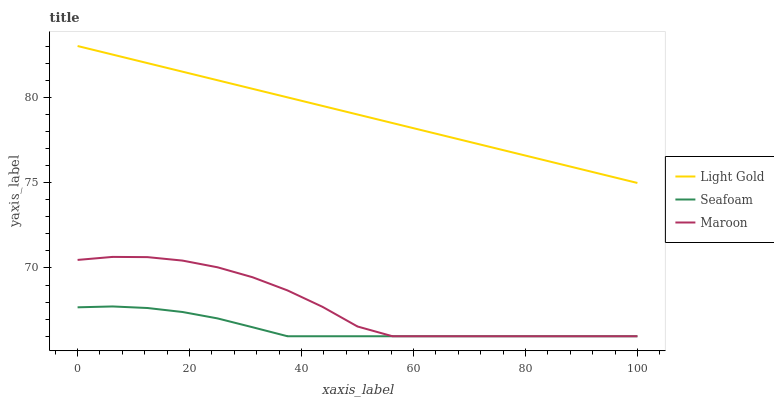Does Seafoam have the minimum area under the curve?
Answer yes or no. Yes. Does Light Gold have the maximum area under the curve?
Answer yes or no. Yes. Does Maroon have the minimum area under the curve?
Answer yes or no. No. Does Maroon have the maximum area under the curve?
Answer yes or no. No. Is Light Gold the smoothest?
Answer yes or no. Yes. Is Maroon the roughest?
Answer yes or no. Yes. Is Seafoam the smoothest?
Answer yes or no. No. Is Seafoam the roughest?
Answer yes or no. No. Does Seafoam have the lowest value?
Answer yes or no. Yes. Does Light Gold have the highest value?
Answer yes or no. Yes. Does Maroon have the highest value?
Answer yes or no. No. Is Maroon less than Light Gold?
Answer yes or no. Yes. Is Light Gold greater than Maroon?
Answer yes or no. Yes. Does Seafoam intersect Maroon?
Answer yes or no. Yes. Is Seafoam less than Maroon?
Answer yes or no. No. Is Seafoam greater than Maroon?
Answer yes or no. No. Does Maroon intersect Light Gold?
Answer yes or no. No. 